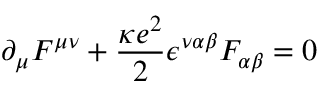Convert formula to latex. <formula><loc_0><loc_0><loc_500><loc_500>\partial _ { \mu } F ^ { \mu \nu } + \frac { \kappa e ^ { 2 } } { 2 } \epsilon ^ { \nu \alpha \beta } F _ { \alpha \beta } = 0</formula> 